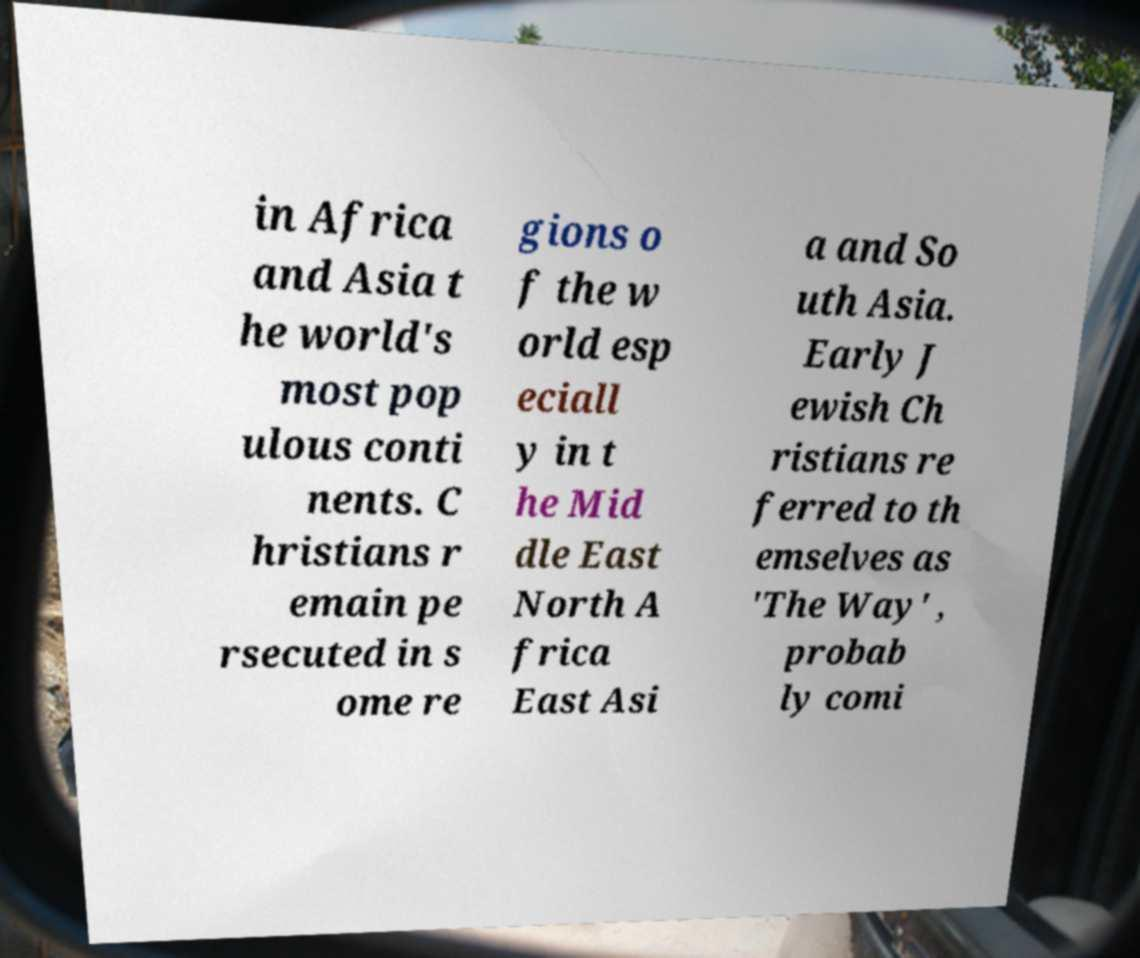Please read and relay the text visible in this image. What does it say? in Africa and Asia t he world's most pop ulous conti nents. C hristians r emain pe rsecuted in s ome re gions o f the w orld esp eciall y in t he Mid dle East North A frica East Asi a and So uth Asia. Early J ewish Ch ristians re ferred to th emselves as 'The Way' , probab ly comi 